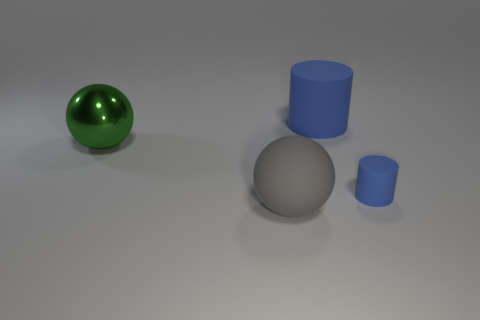What number of things are objects that are behind the big shiny sphere or large things that are to the right of the large gray thing?
Make the answer very short. 1. How many things are either big gray rubber things or large blue matte objects?
Your answer should be compact. 2. What size is the rubber thing that is on the right side of the large gray thing and in front of the big blue matte thing?
Give a very brief answer. Small. How many big purple blocks have the same material as the small cylinder?
Your answer should be very brief. 0. What color is the large cylinder that is the same material as the large gray ball?
Provide a short and direct response. Blue. There is a rubber cylinder that is behind the big green shiny sphere; does it have the same color as the tiny matte thing?
Provide a short and direct response. Yes. There is a sphere that is behind the gray rubber sphere; what material is it?
Give a very brief answer. Metal. Are there an equal number of green spheres in front of the big gray object and big green metal spheres?
Your answer should be compact. No. How many other large spheres are the same color as the shiny ball?
Your answer should be compact. 0. The shiny thing that is the same shape as the big gray matte thing is what color?
Your answer should be compact. Green. 